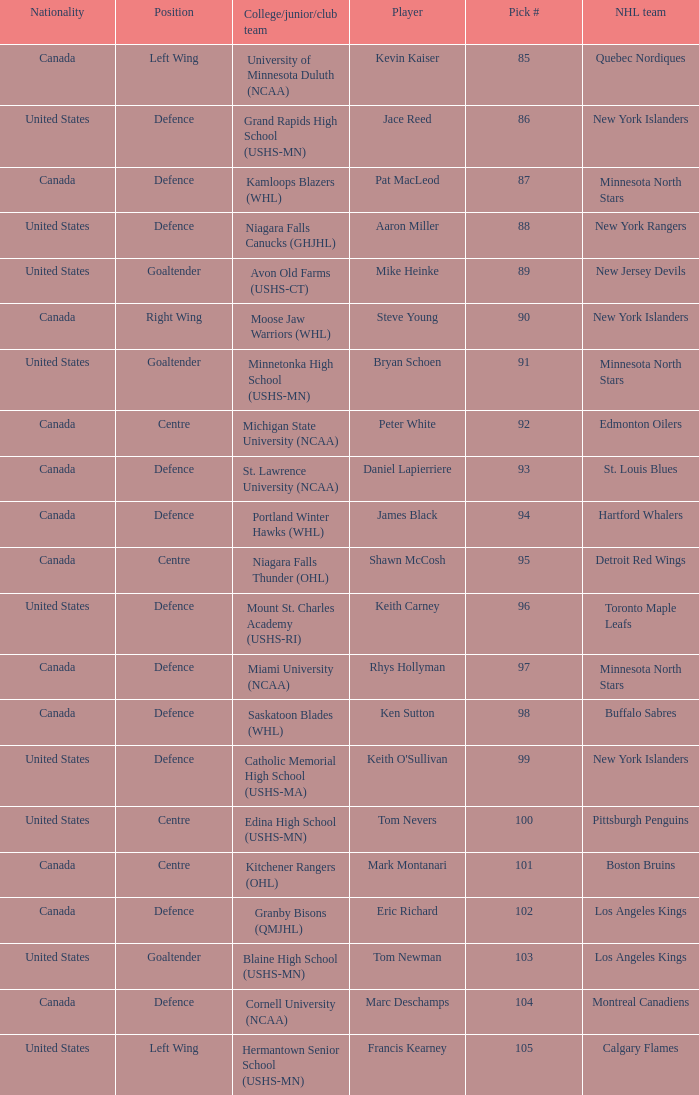What pick number was marc deschamps? 104.0. 